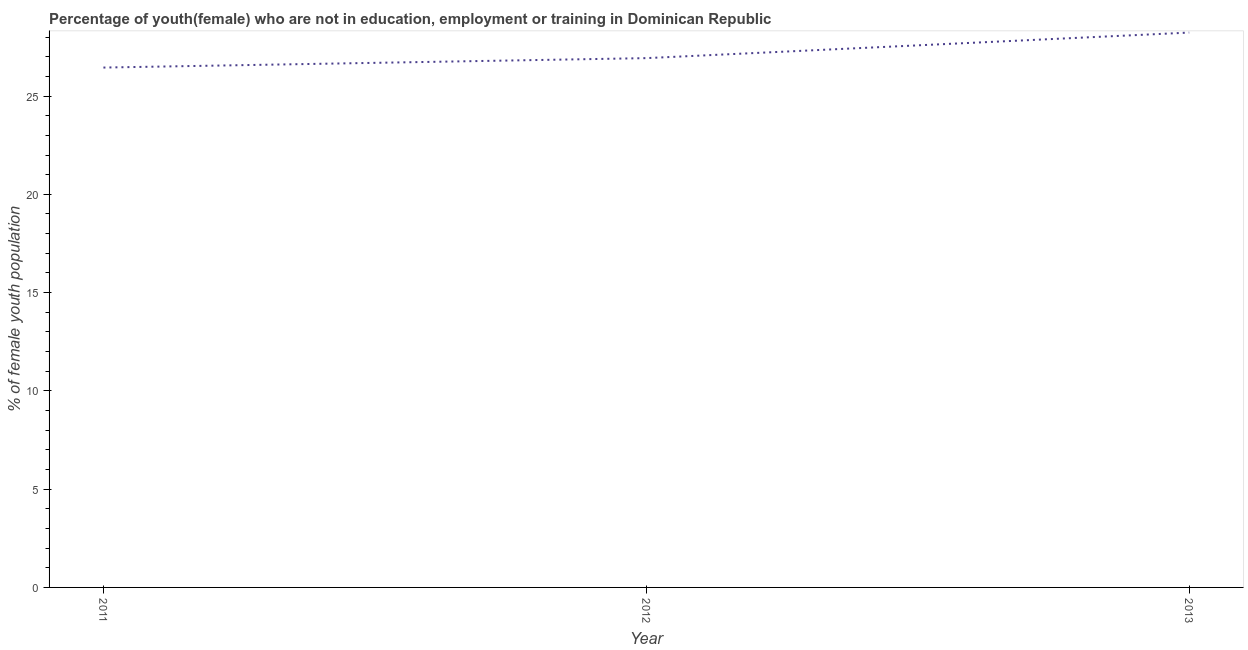What is the unemployed female youth population in 2013?
Ensure brevity in your answer.  28.23. Across all years, what is the maximum unemployed female youth population?
Your answer should be compact. 28.23. Across all years, what is the minimum unemployed female youth population?
Provide a succinct answer. 26.45. In which year was the unemployed female youth population minimum?
Ensure brevity in your answer.  2011. What is the sum of the unemployed female youth population?
Your response must be concise. 81.61. What is the difference between the unemployed female youth population in 2011 and 2013?
Provide a succinct answer. -1.78. What is the average unemployed female youth population per year?
Ensure brevity in your answer.  27.2. What is the median unemployed female youth population?
Ensure brevity in your answer.  26.93. In how many years, is the unemployed female youth population greater than 9 %?
Your response must be concise. 3. Do a majority of the years between 2011 and 2012 (inclusive) have unemployed female youth population greater than 11 %?
Offer a very short reply. Yes. What is the ratio of the unemployed female youth population in 2012 to that in 2013?
Provide a succinct answer. 0.95. Is the difference between the unemployed female youth population in 2011 and 2012 greater than the difference between any two years?
Your answer should be compact. No. What is the difference between the highest and the second highest unemployed female youth population?
Make the answer very short. 1.3. What is the difference between the highest and the lowest unemployed female youth population?
Give a very brief answer. 1.78. How many lines are there?
Provide a succinct answer. 1. How many years are there in the graph?
Offer a terse response. 3. What is the difference between two consecutive major ticks on the Y-axis?
Your answer should be very brief. 5. Are the values on the major ticks of Y-axis written in scientific E-notation?
Provide a succinct answer. No. What is the title of the graph?
Your response must be concise. Percentage of youth(female) who are not in education, employment or training in Dominican Republic. What is the label or title of the X-axis?
Offer a terse response. Year. What is the label or title of the Y-axis?
Offer a very short reply. % of female youth population. What is the % of female youth population of 2011?
Your answer should be very brief. 26.45. What is the % of female youth population of 2012?
Ensure brevity in your answer.  26.93. What is the % of female youth population of 2013?
Provide a succinct answer. 28.23. What is the difference between the % of female youth population in 2011 and 2012?
Offer a very short reply. -0.48. What is the difference between the % of female youth population in 2011 and 2013?
Make the answer very short. -1.78. What is the difference between the % of female youth population in 2012 and 2013?
Give a very brief answer. -1.3. What is the ratio of the % of female youth population in 2011 to that in 2013?
Provide a succinct answer. 0.94. What is the ratio of the % of female youth population in 2012 to that in 2013?
Provide a succinct answer. 0.95. 